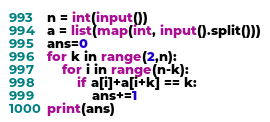<code> <loc_0><loc_0><loc_500><loc_500><_Python_>n = int(input())
a = list(map(int, input().split()))
ans=0
for k in range(2,n):
    for i in range(n-k):
        if a[i]+a[i+k] == k:
            ans+=1
print(ans)</code> 